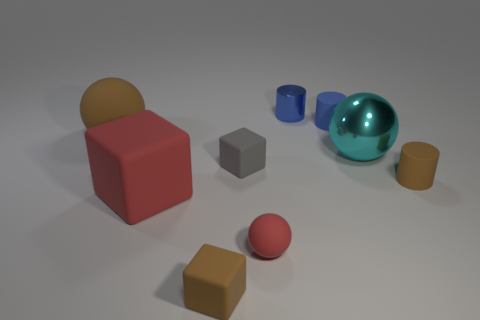Subtract all brown rubber cubes. How many cubes are left? 2 Add 1 small rubber things. How many objects exist? 10 Subtract all blue balls. How many blue cylinders are left? 2 Subtract all spheres. How many objects are left? 6 Subtract 3 balls. How many balls are left? 0 Subtract all blue cylinders. How many cylinders are left? 1 Subtract all purple cubes. Subtract all cyan cylinders. How many cubes are left? 3 Subtract all tiny blue matte objects. Subtract all large red rubber blocks. How many objects are left? 7 Add 2 cyan things. How many cyan things are left? 3 Add 8 small gray spheres. How many small gray spheres exist? 8 